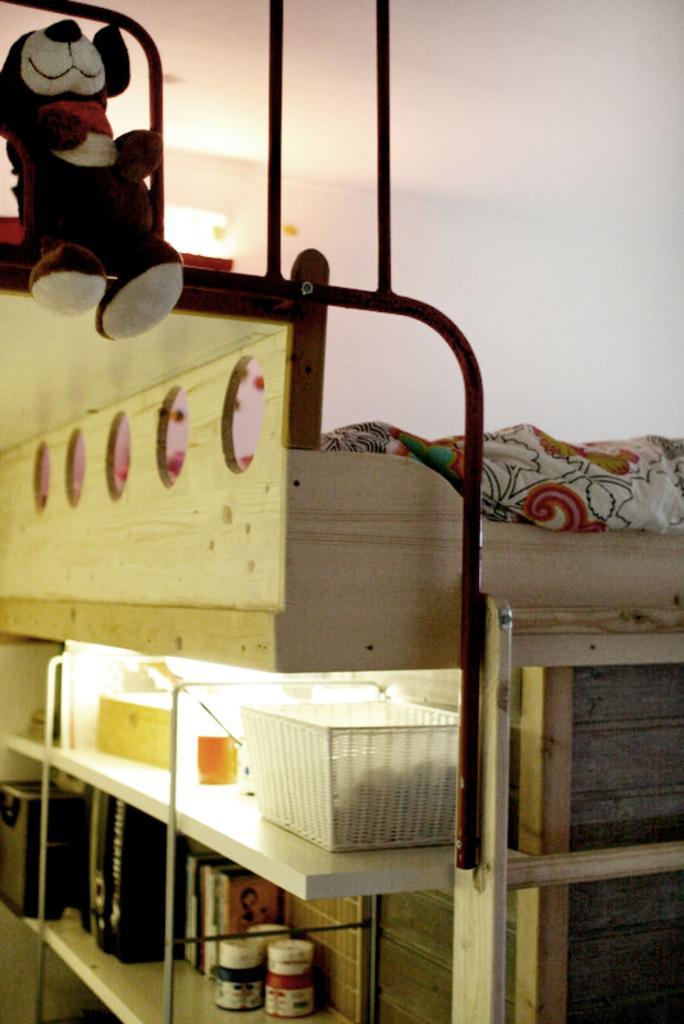Describe this image in one or two sentences. In this picture there is a bottle in the rack. There is a teddy bear on the rod. There is a cloth. There is a cup and a deck in the shelf. 